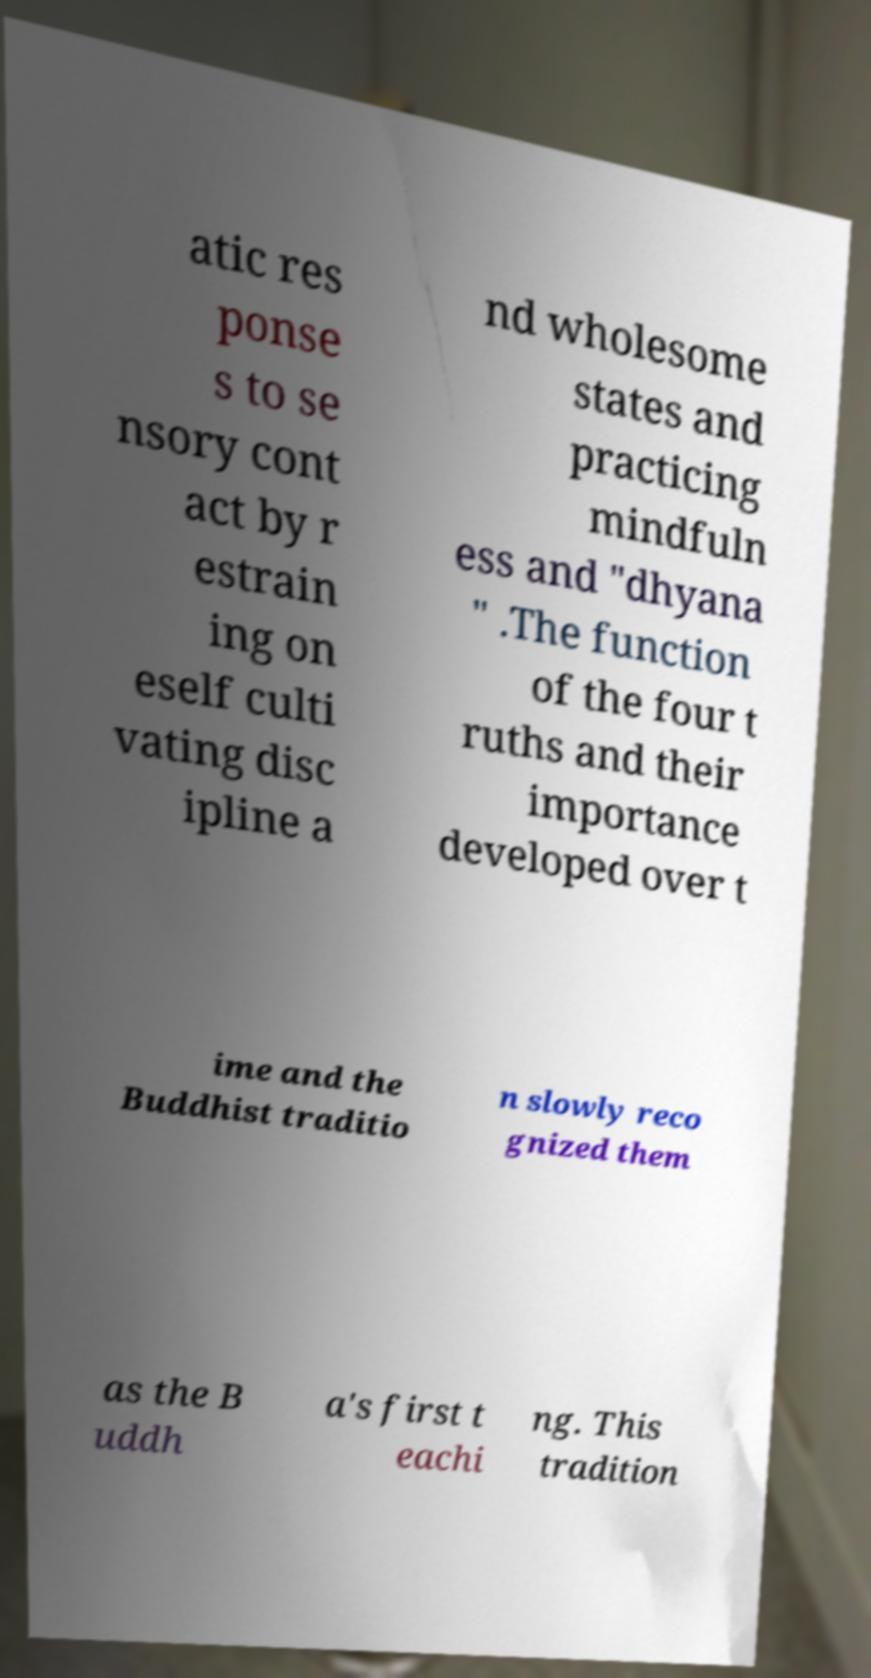I need the written content from this picture converted into text. Can you do that? atic res ponse s to se nsory cont act by r estrain ing on eself culti vating disc ipline a nd wholesome states and practicing mindfuln ess and "dhyana " .The function of the four t ruths and their importance developed over t ime and the Buddhist traditio n slowly reco gnized them as the B uddh a's first t eachi ng. This tradition 